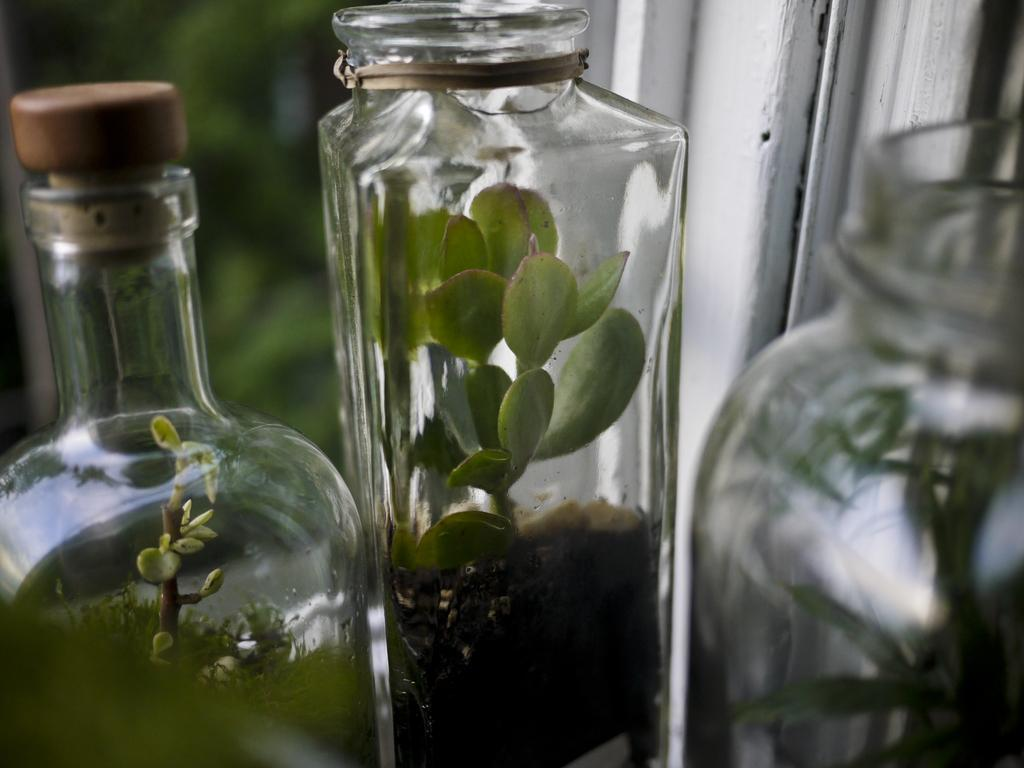What object is placed inside the glass bottle in the image? A tree plant is placed in the glass bottle in the image. How many glass bottles are visible in the image? There are three glass bottles in the image. What can be seen behind the glass bottles in the image? There is a white wall visible in the image. What type of robin can be seen perched on the tree plant in the image? There is no robin present in the image; it only features glass bottles with tree plants inside. 